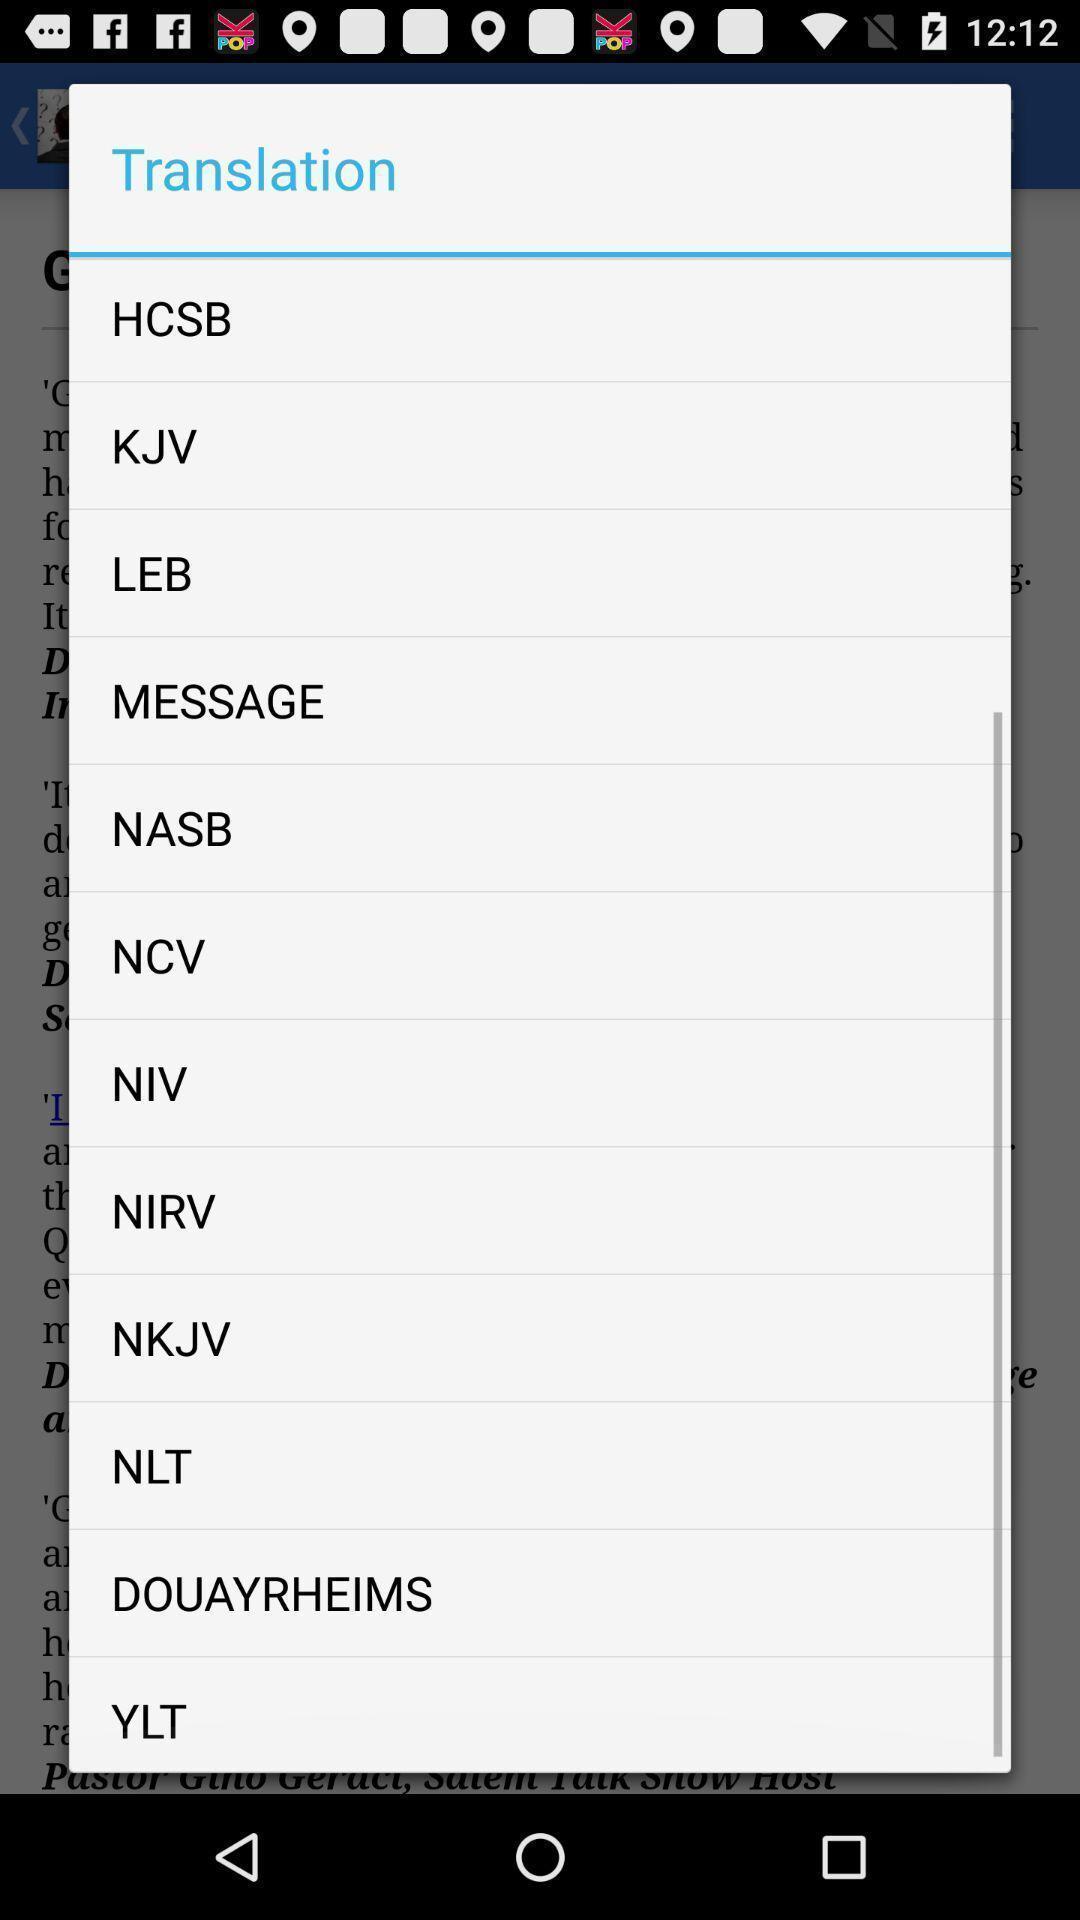Tell me about the visual elements in this screen capture. Pop-up showing the list of options to translate. 